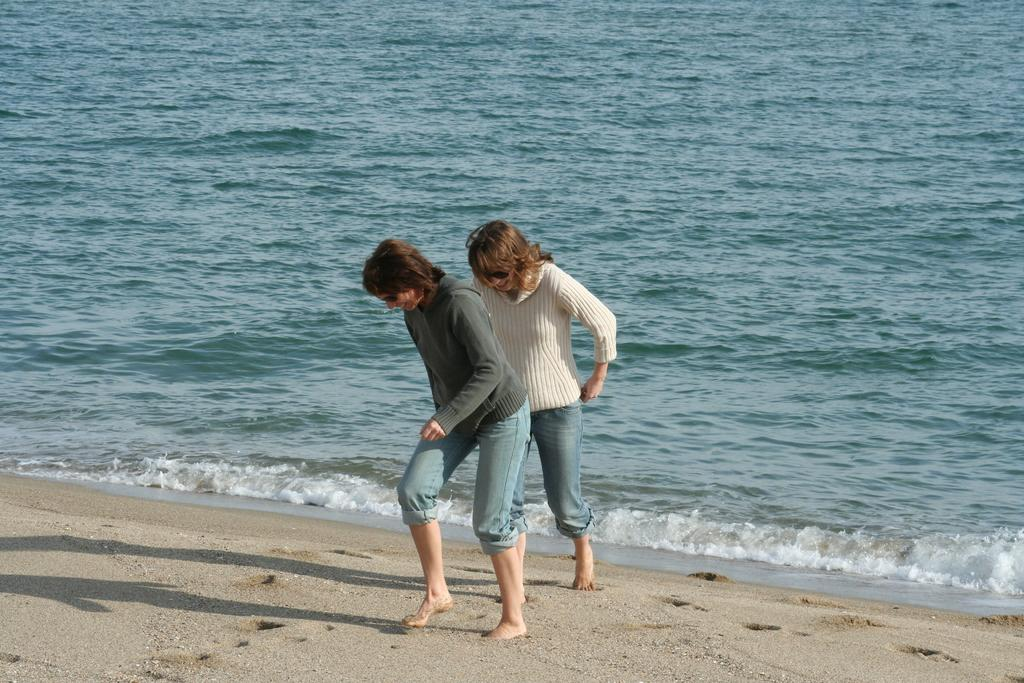How many people are in the image? There are two persons in the image. Where are the persons located? The persons are on a beach. What time of day is the image taken? The image is taken during the day. What can be seen in the background of the image? There is water visible in the background. What type of surface is the beach made of? The beach has sand. What type of pin can be seen holding up the news on the wall in the image? There is no pin, news, or wall present in the image; it features two persons on a beach. 